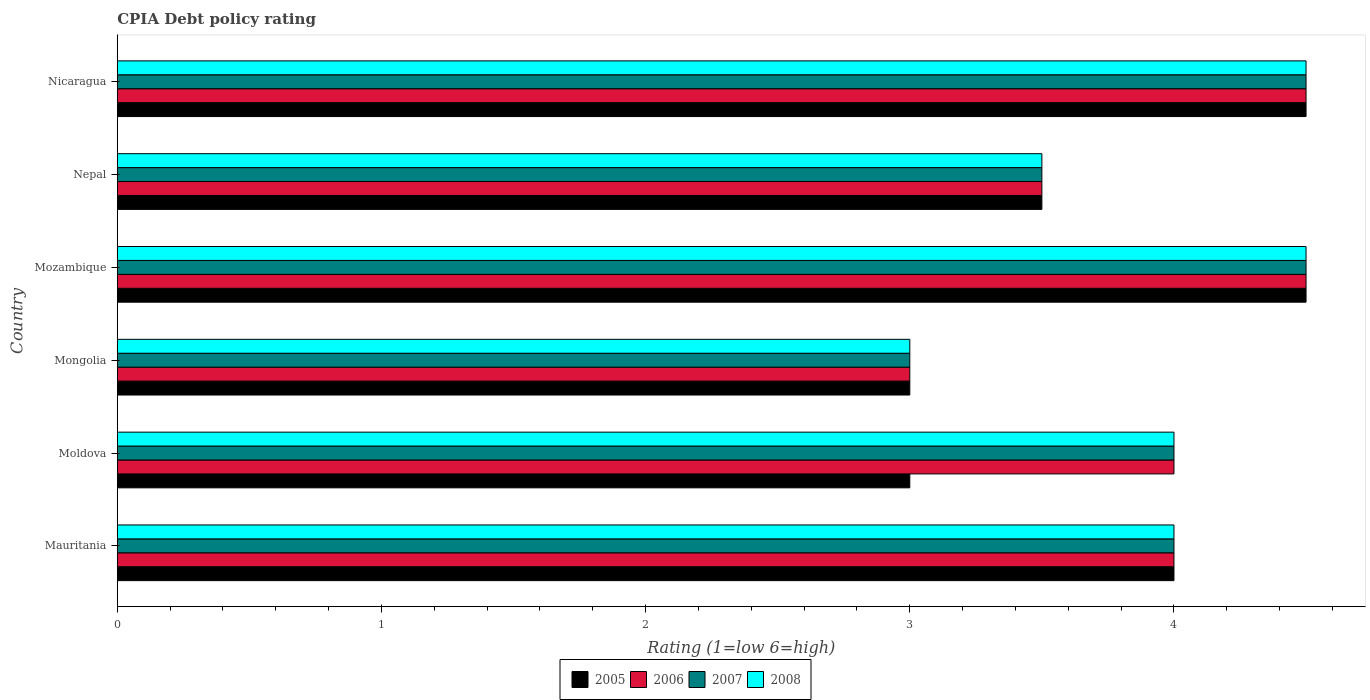How many groups of bars are there?
Offer a very short reply. 6. Are the number of bars on each tick of the Y-axis equal?
Provide a short and direct response. Yes. How many bars are there on the 6th tick from the top?
Make the answer very short. 4. How many bars are there on the 6th tick from the bottom?
Offer a very short reply. 4. What is the label of the 4th group of bars from the top?
Offer a terse response. Mongolia. What is the CPIA rating in 2005 in Mongolia?
Provide a succinct answer. 3. Across all countries, what is the maximum CPIA rating in 2007?
Your answer should be very brief. 4.5. In which country was the CPIA rating in 2007 maximum?
Your answer should be compact. Mozambique. In which country was the CPIA rating in 2007 minimum?
Give a very brief answer. Mongolia. What is the difference between the CPIA rating in 2008 in Nicaragua and the CPIA rating in 2005 in Nepal?
Offer a terse response. 1. What is the average CPIA rating in 2005 per country?
Your answer should be compact. 3.75. What is the difference between the CPIA rating in 2006 and CPIA rating in 2005 in Nicaragua?
Provide a short and direct response. 0. In how many countries, is the CPIA rating in 2007 greater than 0.4 ?
Offer a very short reply. 6. What is the ratio of the CPIA rating in 2005 in Mongolia to that in Nicaragua?
Your answer should be compact. 0.67. Is the CPIA rating in 2006 in Mozambique less than that in Nicaragua?
Provide a succinct answer. No. Is the difference between the CPIA rating in 2006 in Mongolia and Nepal greater than the difference between the CPIA rating in 2005 in Mongolia and Nepal?
Offer a terse response. No. What is the difference between the highest and the second highest CPIA rating in 2008?
Your answer should be very brief. 0. Is it the case that in every country, the sum of the CPIA rating in 2008 and CPIA rating in 2007 is greater than the sum of CPIA rating in 2006 and CPIA rating in 2005?
Keep it short and to the point. No. What does the 2nd bar from the top in Mauritania represents?
Provide a succinct answer. 2007. What does the 1st bar from the bottom in Mauritania represents?
Ensure brevity in your answer.  2005. Is it the case that in every country, the sum of the CPIA rating in 2008 and CPIA rating in 2007 is greater than the CPIA rating in 2005?
Your answer should be very brief. Yes. Are all the bars in the graph horizontal?
Provide a succinct answer. Yes. What is the difference between two consecutive major ticks on the X-axis?
Give a very brief answer. 1. What is the title of the graph?
Your answer should be very brief. CPIA Debt policy rating. What is the label or title of the X-axis?
Your response must be concise. Rating (1=low 6=high). What is the label or title of the Y-axis?
Your answer should be very brief. Country. What is the Rating (1=low 6=high) of 2006 in Mauritania?
Make the answer very short. 4. What is the Rating (1=low 6=high) in 2008 in Mauritania?
Keep it short and to the point. 4. What is the Rating (1=low 6=high) in 2005 in Moldova?
Your answer should be compact. 3. What is the Rating (1=low 6=high) in 2005 in Mongolia?
Offer a terse response. 3. What is the Rating (1=low 6=high) of 2007 in Mongolia?
Offer a very short reply. 3. What is the Rating (1=low 6=high) of 2005 in Mozambique?
Your response must be concise. 4.5. What is the Rating (1=low 6=high) of 2006 in Mozambique?
Give a very brief answer. 4.5. What is the Rating (1=low 6=high) in 2008 in Mozambique?
Your answer should be compact. 4.5. What is the Rating (1=low 6=high) in 2005 in Nepal?
Provide a short and direct response. 3.5. What is the Rating (1=low 6=high) of 2006 in Nepal?
Your response must be concise. 3.5. What is the Rating (1=low 6=high) in 2007 in Nepal?
Your response must be concise. 3.5. What is the Rating (1=low 6=high) of 2005 in Nicaragua?
Your answer should be compact. 4.5. What is the Rating (1=low 6=high) of 2007 in Nicaragua?
Your answer should be compact. 4.5. What is the Rating (1=low 6=high) in 2008 in Nicaragua?
Offer a very short reply. 4.5. Across all countries, what is the maximum Rating (1=low 6=high) of 2005?
Your response must be concise. 4.5. Across all countries, what is the maximum Rating (1=low 6=high) in 2007?
Provide a succinct answer. 4.5. Across all countries, what is the minimum Rating (1=low 6=high) of 2005?
Give a very brief answer. 3. Across all countries, what is the minimum Rating (1=low 6=high) of 2008?
Your answer should be compact. 3. What is the total Rating (1=low 6=high) in 2005 in the graph?
Offer a very short reply. 22.5. What is the total Rating (1=low 6=high) of 2006 in the graph?
Give a very brief answer. 23.5. What is the difference between the Rating (1=low 6=high) in 2005 in Mauritania and that in Moldova?
Your response must be concise. 1. What is the difference between the Rating (1=low 6=high) in 2007 in Mauritania and that in Moldova?
Provide a short and direct response. 0. What is the difference between the Rating (1=low 6=high) of 2006 in Mauritania and that in Mongolia?
Provide a short and direct response. 1. What is the difference between the Rating (1=low 6=high) in 2007 in Mauritania and that in Mozambique?
Your answer should be very brief. -0.5. What is the difference between the Rating (1=low 6=high) of 2008 in Mauritania and that in Mozambique?
Your answer should be compact. -0.5. What is the difference between the Rating (1=low 6=high) in 2007 in Mauritania and that in Nepal?
Your response must be concise. 0.5. What is the difference between the Rating (1=low 6=high) of 2008 in Mauritania and that in Nepal?
Give a very brief answer. 0.5. What is the difference between the Rating (1=low 6=high) in 2005 in Mauritania and that in Nicaragua?
Provide a succinct answer. -0.5. What is the difference between the Rating (1=low 6=high) of 2008 in Mauritania and that in Nicaragua?
Offer a terse response. -0.5. What is the difference between the Rating (1=low 6=high) in 2007 in Moldova and that in Mongolia?
Provide a short and direct response. 1. What is the difference between the Rating (1=low 6=high) of 2006 in Moldova and that in Mozambique?
Your response must be concise. -0.5. What is the difference between the Rating (1=low 6=high) in 2007 in Moldova and that in Mozambique?
Make the answer very short. -0.5. What is the difference between the Rating (1=low 6=high) of 2006 in Moldova and that in Nepal?
Your answer should be very brief. 0.5. What is the difference between the Rating (1=low 6=high) in 2007 in Moldova and that in Nepal?
Give a very brief answer. 0.5. What is the difference between the Rating (1=low 6=high) in 2008 in Moldova and that in Nepal?
Provide a short and direct response. 0.5. What is the difference between the Rating (1=low 6=high) in 2007 in Moldova and that in Nicaragua?
Offer a very short reply. -0.5. What is the difference between the Rating (1=low 6=high) of 2008 in Moldova and that in Nicaragua?
Make the answer very short. -0.5. What is the difference between the Rating (1=low 6=high) in 2007 in Mongolia and that in Mozambique?
Give a very brief answer. -1.5. What is the difference between the Rating (1=low 6=high) of 2006 in Mongolia and that in Nepal?
Provide a succinct answer. -0.5. What is the difference between the Rating (1=low 6=high) of 2005 in Mongolia and that in Nicaragua?
Offer a very short reply. -1.5. What is the difference between the Rating (1=low 6=high) in 2007 in Mongolia and that in Nicaragua?
Offer a terse response. -1.5. What is the difference between the Rating (1=low 6=high) in 2005 in Mozambique and that in Nepal?
Ensure brevity in your answer.  1. What is the difference between the Rating (1=low 6=high) of 2007 in Mozambique and that in Nepal?
Your response must be concise. 1. What is the difference between the Rating (1=low 6=high) of 2008 in Mozambique and that in Nepal?
Give a very brief answer. 1. What is the difference between the Rating (1=low 6=high) in 2005 in Mozambique and that in Nicaragua?
Your answer should be compact. 0. What is the difference between the Rating (1=low 6=high) in 2007 in Mozambique and that in Nicaragua?
Ensure brevity in your answer.  0. What is the difference between the Rating (1=low 6=high) in 2005 in Nepal and that in Nicaragua?
Offer a very short reply. -1. What is the difference between the Rating (1=low 6=high) in 2005 in Mauritania and the Rating (1=low 6=high) in 2006 in Moldova?
Provide a short and direct response. 0. What is the difference between the Rating (1=low 6=high) in 2005 in Mauritania and the Rating (1=low 6=high) in 2008 in Moldova?
Provide a short and direct response. 0. What is the difference between the Rating (1=low 6=high) of 2006 in Mauritania and the Rating (1=low 6=high) of 2007 in Moldova?
Provide a short and direct response. 0. What is the difference between the Rating (1=low 6=high) in 2005 in Mauritania and the Rating (1=low 6=high) in 2006 in Mongolia?
Ensure brevity in your answer.  1. What is the difference between the Rating (1=low 6=high) of 2006 in Mauritania and the Rating (1=low 6=high) of 2007 in Mongolia?
Provide a succinct answer. 1. What is the difference between the Rating (1=low 6=high) of 2005 in Mauritania and the Rating (1=low 6=high) of 2007 in Mozambique?
Offer a very short reply. -0.5. What is the difference between the Rating (1=low 6=high) in 2007 in Mauritania and the Rating (1=low 6=high) in 2008 in Mozambique?
Your answer should be very brief. -0.5. What is the difference between the Rating (1=low 6=high) of 2005 in Mauritania and the Rating (1=low 6=high) of 2006 in Nepal?
Provide a short and direct response. 0.5. What is the difference between the Rating (1=low 6=high) of 2005 in Mauritania and the Rating (1=low 6=high) of 2007 in Nepal?
Provide a short and direct response. 0.5. What is the difference between the Rating (1=low 6=high) of 2006 in Mauritania and the Rating (1=low 6=high) of 2007 in Nepal?
Offer a very short reply. 0.5. What is the difference between the Rating (1=low 6=high) in 2006 in Mauritania and the Rating (1=low 6=high) in 2008 in Nepal?
Provide a short and direct response. 0.5. What is the difference between the Rating (1=low 6=high) of 2006 in Mauritania and the Rating (1=low 6=high) of 2007 in Nicaragua?
Give a very brief answer. -0.5. What is the difference between the Rating (1=low 6=high) of 2005 in Moldova and the Rating (1=low 6=high) of 2006 in Mongolia?
Your answer should be very brief. 0. What is the difference between the Rating (1=low 6=high) of 2005 in Moldova and the Rating (1=low 6=high) of 2008 in Mongolia?
Provide a succinct answer. 0. What is the difference between the Rating (1=low 6=high) of 2006 in Moldova and the Rating (1=low 6=high) of 2008 in Mongolia?
Make the answer very short. 1. What is the difference between the Rating (1=low 6=high) in 2007 in Moldova and the Rating (1=low 6=high) in 2008 in Mongolia?
Offer a very short reply. 1. What is the difference between the Rating (1=low 6=high) in 2005 in Moldova and the Rating (1=low 6=high) in 2006 in Mozambique?
Your answer should be very brief. -1.5. What is the difference between the Rating (1=low 6=high) in 2005 in Moldova and the Rating (1=low 6=high) in 2008 in Mozambique?
Your answer should be compact. -1.5. What is the difference between the Rating (1=low 6=high) in 2006 in Moldova and the Rating (1=low 6=high) in 2007 in Mozambique?
Give a very brief answer. -0.5. What is the difference between the Rating (1=low 6=high) of 2007 in Moldova and the Rating (1=low 6=high) of 2008 in Mozambique?
Your answer should be compact. -0.5. What is the difference between the Rating (1=low 6=high) in 2005 in Moldova and the Rating (1=low 6=high) in 2006 in Nicaragua?
Offer a terse response. -1.5. What is the difference between the Rating (1=low 6=high) in 2006 in Moldova and the Rating (1=low 6=high) in 2008 in Nicaragua?
Offer a very short reply. -0.5. What is the difference between the Rating (1=low 6=high) in 2007 in Moldova and the Rating (1=low 6=high) in 2008 in Nicaragua?
Your answer should be compact. -0.5. What is the difference between the Rating (1=low 6=high) in 2005 in Mongolia and the Rating (1=low 6=high) in 2006 in Mozambique?
Your answer should be compact. -1.5. What is the difference between the Rating (1=low 6=high) in 2005 in Mongolia and the Rating (1=low 6=high) in 2007 in Mozambique?
Offer a very short reply. -1.5. What is the difference between the Rating (1=low 6=high) of 2005 in Mongolia and the Rating (1=low 6=high) of 2008 in Mozambique?
Provide a succinct answer. -1.5. What is the difference between the Rating (1=low 6=high) of 2006 in Mongolia and the Rating (1=low 6=high) of 2008 in Nepal?
Ensure brevity in your answer.  -0.5. What is the difference between the Rating (1=low 6=high) of 2005 in Mongolia and the Rating (1=low 6=high) of 2006 in Nicaragua?
Offer a terse response. -1.5. What is the difference between the Rating (1=low 6=high) of 2005 in Mongolia and the Rating (1=low 6=high) of 2008 in Nicaragua?
Provide a succinct answer. -1.5. What is the difference between the Rating (1=low 6=high) of 2006 in Mongolia and the Rating (1=low 6=high) of 2007 in Nicaragua?
Give a very brief answer. -1.5. What is the difference between the Rating (1=low 6=high) in 2005 in Mozambique and the Rating (1=low 6=high) in 2007 in Nepal?
Your response must be concise. 1. What is the difference between the Rating (1=low 6=high) in 2005 in Mozambique and the Rating (1=low 6=high) in 2008 in Nicaragua?
Provide a short and direct response. 0. What is the difference between the Rating (1=low 6=high) in 2006 in Mozambique and the Rating (1=low 6=high) in 2008 in Nicaragua?
Your answer should be very brief. 0. What is the difference between the Rating (1=low 6=high) of 2007 in Mozambique and the Rating (1=low 6=high) of 2008 in Nicaragua?
Your response must be concise. 0. What is the difference between the Rating (1=low 6=high) in 2005 in Nepal and the Rating (1=low 6=high) in 2007 in Nicaragua?
Provide a short and direct response. -1. What is the difference between the Rating (1=low 6=high) in 2006 in Nepal and the Rating (1=low 6=high) in 2007 in Nicaragua?
Offer a terse response. -1. What is the difference between the Rating (1=low 6=high) in 2006 in Nepal and the Rating (1=low 6=high) in 2008 in Nicaragua?
Offer a very short reply. -1. What is the average Rating (1=low 6=high) in 2005 per country?
Keep it short and to the point. 3.75. What is the average Rating (1=low 6=high) in 2006 per country?
Offer a very short reply. 3.92. What is the average Rating (1=low 6=high) in 2007 per country?
Make the answer very short. 3.92. What is the average Rating (1=low 6=high) of 2008 per country?
Keep it short and to the point. 3.92. What is the difference between the Rating (1=low 6=high) in 2006 and Rating (1=low 6=high) in 2008 in Mauritania?
Provide a succinct answer. 0. What is the difference between the Rating (1=low 6=high) in 2005 and Rating (1=low 6=high) in 2007 in Moldova?
Make the answer very short. -1. What is the difference between the Rating (1=low 6=high) in 2006 and Rating (1=low 6=high) in 2007 in Moldova?
Your response must be concise. 0. What is the difference between the Rating (1=low 6=high) of 2005 and Rating (1=low 6=high) of 2006 in Mongolia?
Offer a terse response. 0. What is the difference between the Rating (1=low 6=high) of 2005 and Rating (1=low 6=high) of 2007 in Mongolia?
Your answer should be very brief. 0. What is the difference between the Rating (1=low 6=high) of 2005 and Rating (1=low 6=high) of 2008 in Mongolia?
Give a very brief answer. 0. What is the difference between the Rating (1=low 6=high) of 2006 and Rating (1=low 6=high) of 2007 in Mongolia?
Give a very brief answer. 0. What is the difference between the Rating (1=low 6=high) in 2006 and Rating (1=low 6=high) in 2008 in Mongolia?
Give a very brief answer. 0. What is the difference between the Rating (1=low 6=high) in 2007 and Rating (1=low 6=high) in 2008 in Mongolia?
Keep it short and to the point. 0. What is the difference between the Rating (1=low 6=high) in 2005 and Rating (1=low 6=high) in 2008 in Mozambique?
Ensure brevity in your answer.  0. What is the difference between the Rating (1=low 6=high) in 2007 and Rating (1=low 6=high) in 2008 in Mozambique?
Make the answer very short. 0. What is the difference between the Rating (1=low 6=high) in 2005 and Rating (1=low 6=high) in 2007 in Nepal?
Give a very brief answer. 0. What is the difference between the Rating (1=low 6=high) of 2005 and Rating (1=low 6=high) of 2007 in Nicaragua?
Your answer should be compact. 0. What is the difference between the Rating (1=low 6=high) in 2005 and Rating (1=low 6=high) in 2008 in Nicaragua?
Provide a short and direct response. 0. What is the ratio of the Rating (1=low 6=high) of 2006 in Mauritania to that in Moldova?
Your answer should be compact. 1. What is the ratio of the Rating (1=low 6=high) of 2008 in Mauritania to that in Moldova?
Your answer should be very brief. 1. What is the ratio of the Rating (1=low 6=high) in 2005 in Mauritania to that in Mongolia?
Provide a succinct answer. 1.33. What is the ratio of the Rating (1=low 6=high) of 2006 in Mauritania to that in Mongolia?
Provide a succinct answer. 1.33. What is the ratio of the Rating (1=low 6=high) in 2008 in Mauritania to that in Mongolia?
Offer a very short reply. 1.33. What is the ratio of the Rating (1=low 6=high) of 2006 in Mauritania to that in Mozambique?
Make the answer very short. 0.89. What is the ratio of the Rating (1=low 6=high) of 2007 in Mauritania to that in Mozambique?
Offer a terse response. 0.89. What is the ratio of the Rating (1=low 6=high) of 2008 in Mauritania to that in Mozambique?
Offer a terse response. 0.89. What is the ratio of the Rating (1=low 6=high) in 2005 in Mauritania to that in Nepal?
Ensure brevity in your answer.  1.14. What is the ratio of the Rating (1=low 6=high) of 2006 in Mauritania to that in Nepal?
Provide a succinct answer. 1.14. What is the ratio of the Rating (1=low 6=high) in 2007 in Mauritania to that in Nepal?
Your answer should be very brief. 1.14. What is the ratio of the Rating (1=low 6=high) in 2008 in Mauritania to that in Nepal?
Keep it short and to the point. 1.14. What is the ratio of the Rating (1=low 6=high) of 2005 in Mauritania to that in Nicaragua?
Make the answer very short. 0.89. What is the ratio of the Rating (1=low 6=high) of 2006 in Mauritania to that in Nicaragua?
Make the answer very short. 0.89. What is the ratio of the Rating (1=low 6=high) of 2007 in Mauritania to that in Nicaragua?
Your answer should be very brief. 0.89. What is the ratio of the Rating (1=low 6=high) in 2005 in Moldova to that in Mongolia?
Your answer should be very brief. 1. What is the ratio of the Rating (1=low 6=high) in 2006 in Moldova to that in Mongolia?
Your answer should be compact. 1.33. What is the ratio of the Rating (1=low 6=high) of 2007 in Moldova to that in Mongolia?
Provide a short and direct response. 1.33. What is the ratio of the Rating (1=low 6=high) of 2005 in Moldova to that in Mozambique?
Provide a short and direct response. 0.67. What is the ratio of the Rating (1=low 6=high) in 2006 in Moldova to that in Mozambique?
Provide a succinct answer. 0.89. What is the ratio of the Rating (1=low 6=high) of 2008 in Moldova to that in Mozambique?
Ensure brevity in your answer.  0.89. What is the ratio of the Rating (1=low 6=high) of 2005 in Moldova to that in Nepal?
Provide a succinct answer. 0.86. What is the ratio of the Rating (1=low 6=high) in 2007 in Moldova to that in Nepal?
Provide a succinct answer. 1.14. What is the ratio of the Rating (1=low 6=high) in 2005 in Moldova to that in Nicaragua?
Your answer should be very brief. 0.67. What is the ratio of the Rating (1=low 6=high) in 2006 in Moldova to that in Nicaragua?
Give a very brief answer. 0.89. What is the ratio of the Rating (1=low 6=high) in 2007 in Moldova to that in Nicaragua?
Give a very brief answer. 0.89. What is the ratio of the Rating (1=low 6=high) of 2005 in Mongolia to that in Mozambique?
Make the answer very short. 0.67. What is the ratio of the Rating (1=low 6=high) in 2008 in Mongolia to that in Mozambique?
Make the answer very short. 0.67. What is the ratio of the Rating (1=low 6=high) of 2006 in Mongolia to that in Nepal?
Make the answer very short. 0.86. What is the ratio of the Rating (1=low 6=high) of 2007 in Mongolia to that in Nicaragua?
Make the answer very short. 0.67. What is the ratio of the Rating (1=low 6=high) in 2005 in Mozambique to that in Nepal?
Provide a succinct answer. 1.29. What is the ratio of the Rating (1=low 6=high) of 2006 in Mozambique to that in Nepal?
Provide a succinct answer. 1.29. What is the ratio of the Rating (1=low 6=high) of 2008 in Mozambique to that in Nepal?
Offer a terse response. 1.29. What is the ratio of the Rating (1=low 6=high) of 2007 in Mozambique to that in Nicaragua?
Provide a succinct answer. 1. What is the ratio of the Rating (1=low 6=high) of 2007 in Nepal to that in Nicaragua?
Your response must be concise. 0.78. What is the ratio of the Rating (1=low 6=high) of 2008 in Nepal to that in Nicaragua?
Provide a succinct answer. 0.78. What is the difference between the highest and the second highest Rating (1=low 6=high) in 2005?
Provide a short and direct response. 0. What is the difference between the highest and the second highest Rating (1=low 6=high) in 2006?
Ensure brevity in your answer.  0. What is the difference between the highest and the second highest Rating (1=low 6=high) of 2007?
Provide a succinct answer. 0. What is the difference between the highest and the lowest Rating (1=low 6=high) of 2005?
Make the answer very short. 1.5. What is the difference between the highest and the lowest Rating (1=low 6=high) in 2006?
Ensure brevity in your answer.  1.5. 